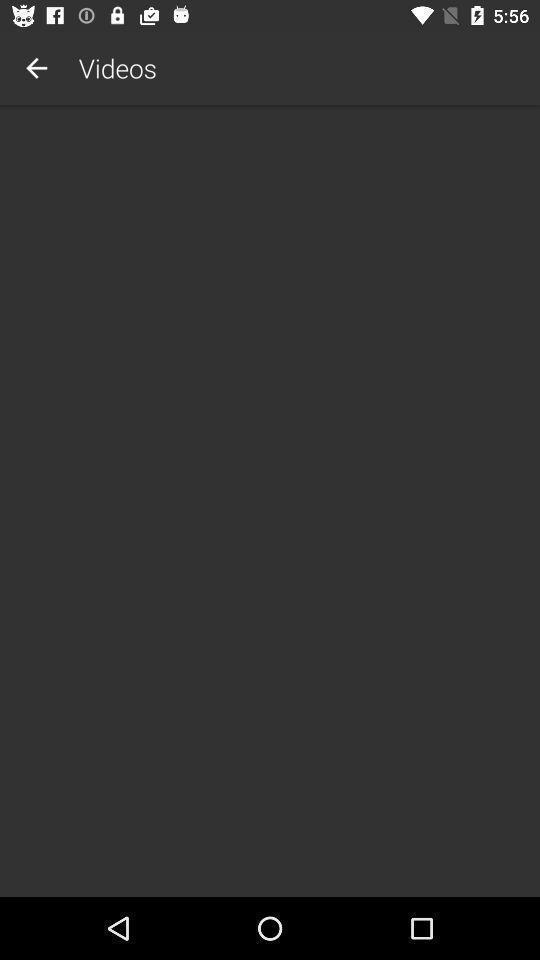What is the overall content of this screenshot? Display page of videos in application. 